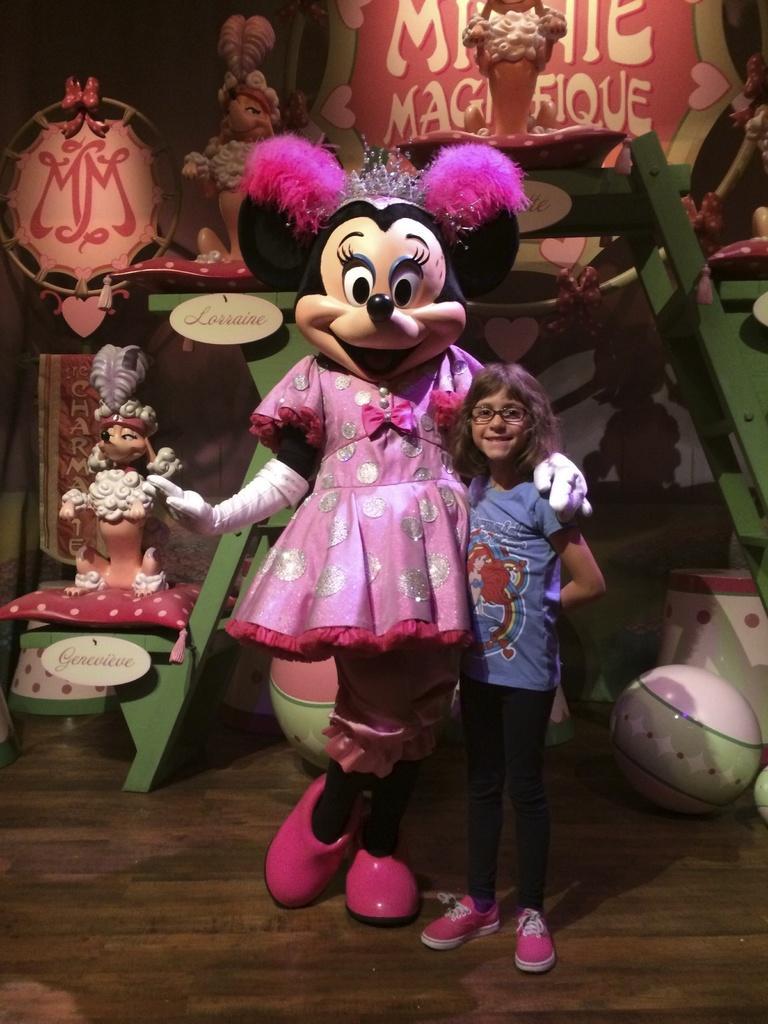Can you describe this image briefly? In this image in the center there is one girl who is standing and there is one toy, in the background there are some toys and ladder and some boxes. At the bottom there is a floor. 